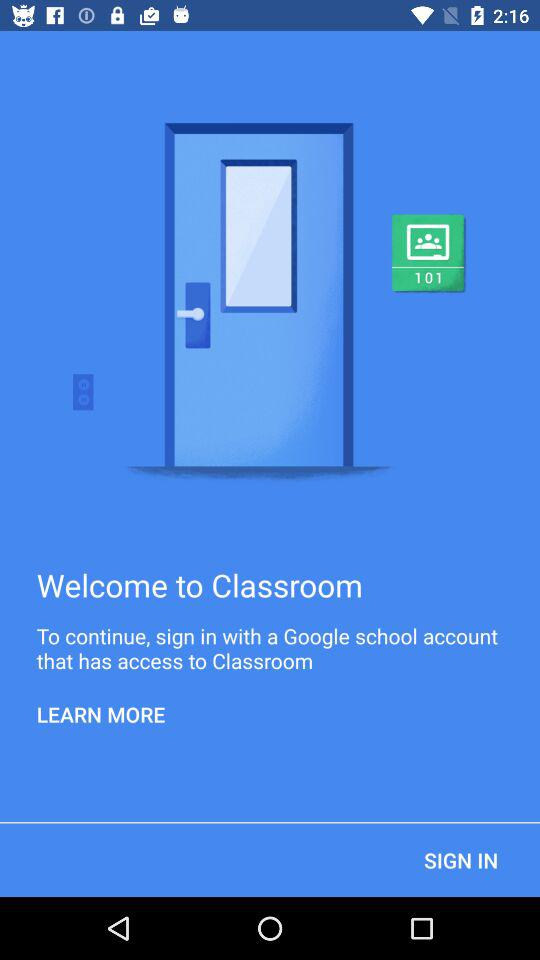What account can we use to sign in? You can use a "Google school" account to sign in. 